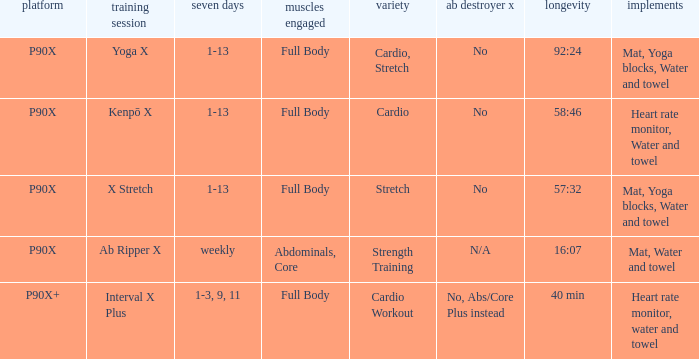Can you give me this table as a dict? {'header': ['platform', 'training session', 'seven days', 'muscles engaged', 'variety', 'ab destroyer x', 'longevity', 'implements'], 'rows': [['P90X', 'Yoga X', '1-13', 'Full Body', 'Cardio, Stretch', 'No', '92:24', 'Mat, Yoga blocks, Water and towel'], ['P90X', 'Kenpō X', '1-13', 'Full Body', 'Cardio', 'No', '58:46', 'Heart rate monitor, Water and towel'], ['P90X', 'X Stretch', '1-13', 'Full Body', 'Stretch', 'No', '57:32', 'Mat, Yoga blocks, Water and towel'], ['P90X', 'Ab Ripper X', 'weekly', 'Abdominals, Core', 'Strength Training', 'N/A', '16:07', 'Mat, Water and towel'], ['P90X+', 'Interval X Plus', '1-3, 9, 11', 'Full Body', 'Cardio Workout', 'No, Abs/Core Plus instead', '40 min', 'Heart rate monitor, water and towel']]} What is the ab ripper x when the length is 92:24? No. 